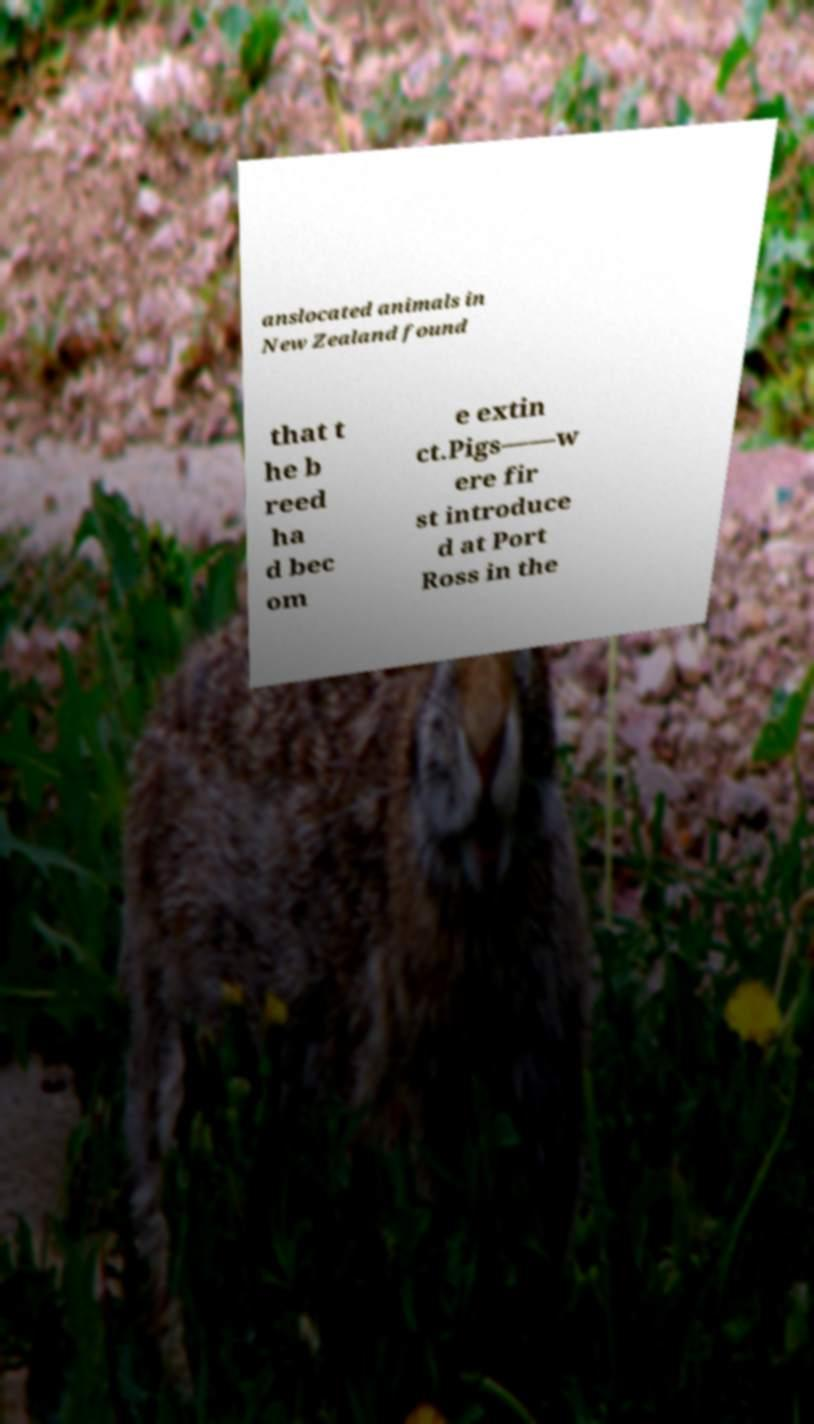Please read and relay the text visible in this image. What does it say? anslocated animals in New Zealand found that t he b reed ha d bec om e extin ct.Pigs——w ere fir st introduce d at Port Ross in the 